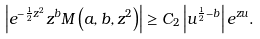<formula> <loc_0><loc_0><loc_500><loc_500>\left | e ^ { - \frac { 1 } { 2 } z ^ { 2 } } z ^ { b } M \left ( a , b , z ^ { 2 } \right ) \right | \geq C _ { 2 } \left | u ^ { \frac { 1 } { 2 } - b } \right | e ^ { z u } .</formula> 